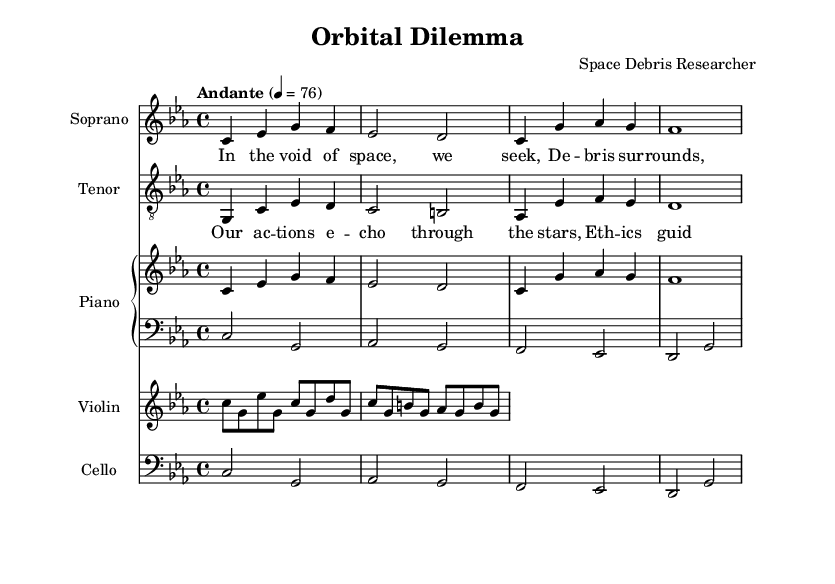What is the key signature of this music? The key signature is C minor, which has three flats (B♭, E♭, and A♭). This is determined by looking at the key signature indication at the beginning of the score.
Answer: C minor What is the time signature of the piece? The time signature is 4/4, meaning there are four beats per measure and the quarter note receives one beat. This is indicated at the beginning of the music notation.
Answer: 4/4 What is the tempo marking of the piece? The tempo is marked as Andante, which indicates a moderately slow pace. This can be seen directly in the tempo marking at the start of the score.
Answer: Andante How many measures are in the soprano section? The soprano section has four measures, which can be counted by looking at the notation and noting the bar lines separating each measure.
Answer: 4 What musical instruments are featured in this opera piece? The piece features a soprano, tenor, piano, violin, and cello. This is indicated by the instrument names listed at the beginning of each staff in the score.
Answer: Soprano, Tenor, Piano, Violin, Cello What is the last note of the tenor part? The last note of the tenor part is D. This can be identified by examining the final note in the tenor staff.
Answer: D Which voice starts with the lyrics "In the void of space, we seek"? The soprano voice starts with the lyrics "In the void of space, we seek." This can be inferred by locating the specific lyrics associated with the soprano music line.
Answer: Soprano 